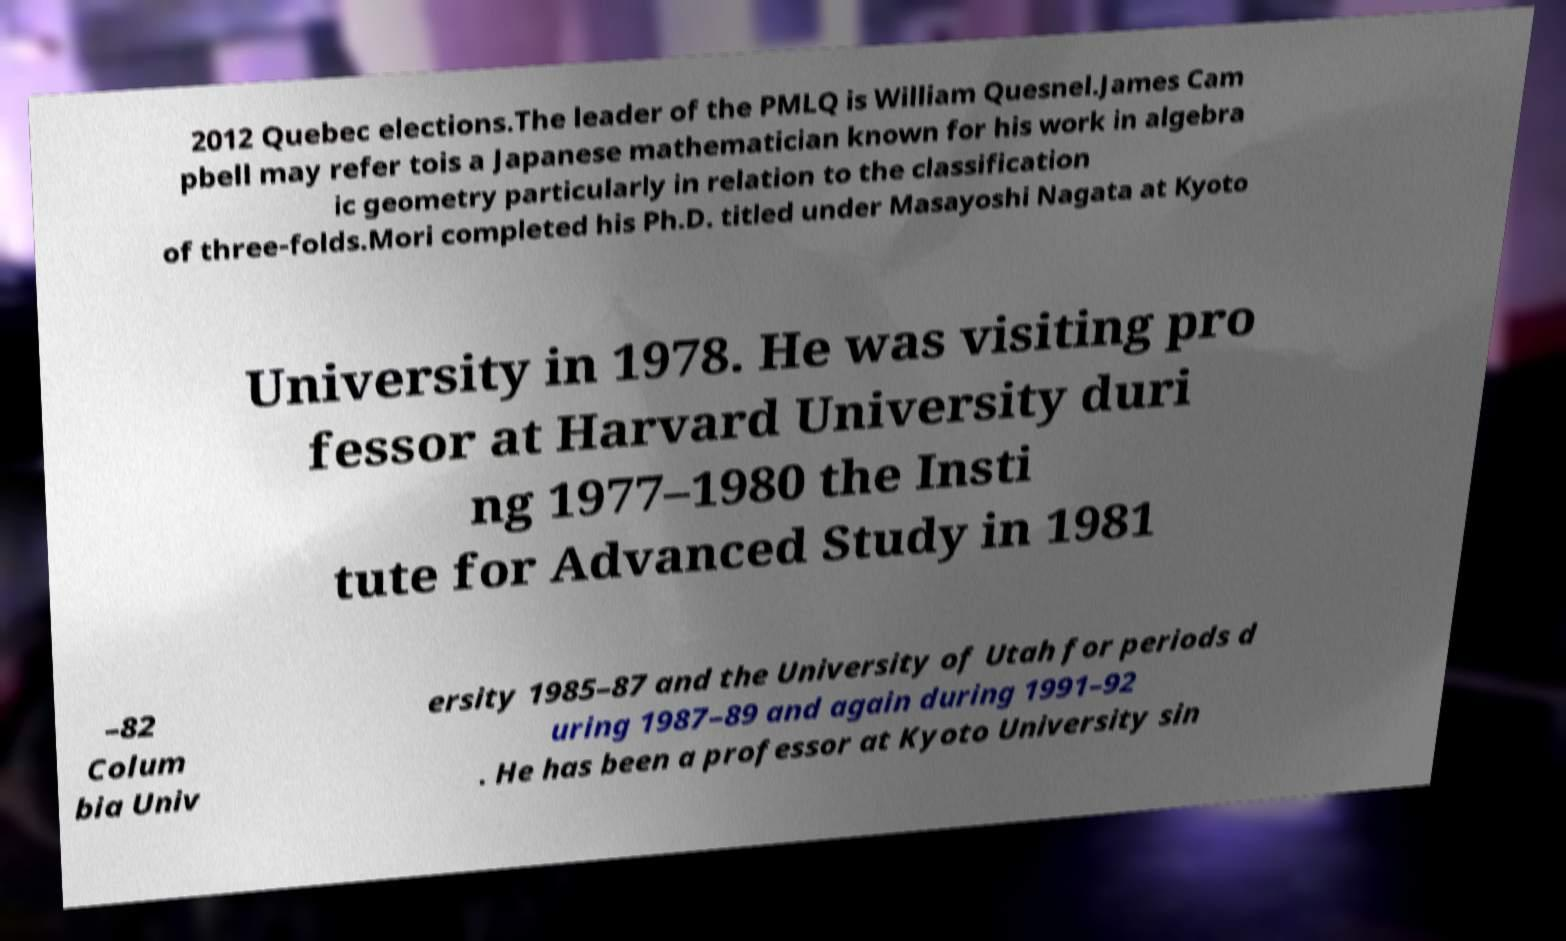What messages or text are displayed in this image? I need them in a readable, typed format. 2012 Quebec elections.The leader of the PMLQ is William Quesnel.James Cam pbell may refer tois a Japanese mathematician known for his work in algebra ic geometry particularly in relation to the classification of three-folds.Mori completed his Ph.D. titled under Masayoshi Nagata at Kyoto University in 1978. He was visiting pro fessor at Harvard University duri ng 1977–1980 the Insti tute for Advanced Study in 1981 –82 Colum bia Univ ersity 1985–87 and the University of Utah for periods d uring 1987–89 and again during 1991–92 . He has been a professor at Kyoto University sin 